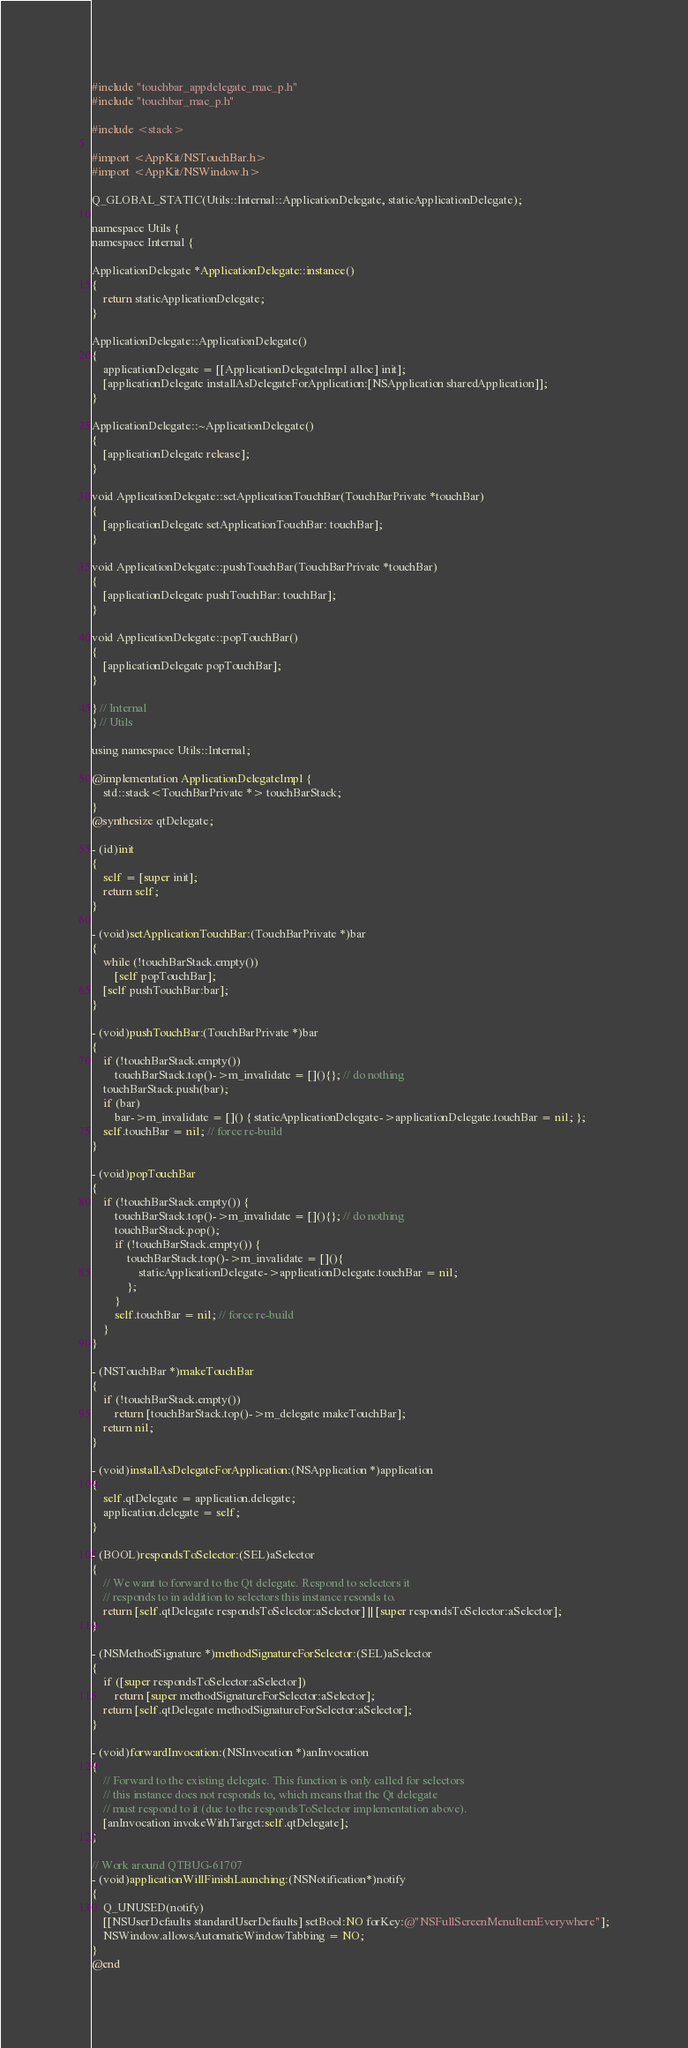<code> <loc_0><loc_0><loc_500><loc_500><_ObjectiveC_>#include "touchbar_appdelegate_mac_p.h"
#include "touchbar_mac_p.h"

#include <stack>

#import <AppKit/NSTouchBar.h>
#import <AppKit/NSWindow.h>

Q_GLOBAL_STATIC(Utils::Internal::ApplicationDelegate, staticApplicationDelegate);

namespace Utils {
namespace Internal {

ApplicationDelegate *ApplicationDelegate::instance()
{
    return staticApplicationDelegate;
}

ApplicationDelegate::ApplicationDelegate()
{
    applicationDelegate = [[ApplicationDelegateImpl alloc] init];
    [applicationDelegate installAsDelegateForApplication:[NSApplication sharedApplication]];
}

ApplicationDelegate::~ApplicationDelegate()
{
    [applicationDelegate release];
}

void ApplicationDelegate::setApplicationTouchBar(TouchBarPrivate *touchBar)
{
    [applicationDelegate setApplicationTouchBar: touchBar];
}

void ApplicationDelegate::pushTouchBar(TouchBarPrivate *touchBar)
{
    [applicationDelegate pushTouchBar: touchBar];
}

void ApplicationDelegate::popTouchBar()
{
    [applicationDelegate popTouchBar];
}

} // Internal
} // Utils

using namespace Utils::Internal;

@implementation ApplicationDelegateImpl {
    std::stack<TouchBarPrivate *> touchBarStack;
}
@synthesize qtDelegate;

- (id)init
{
    self = [super init];
    return self;
}

- (void)setApplicationTouchBar:(TouchBarPrivate *)bar
{
    while (!touchBarStack.empty())
        [self popTouchBar];
    [self pushTouchBar:bar];
}

- (void)pushTouchBar:(TouchBarPrivate *)bar
{
    if (!touchBarStack.empty())
        touchBarStack.top()->m_invalidate = [](){}; // do nothing
    touchBarStack.push(bar);
    if (bar)
        bar->m_invalidate = []() { staticApplicationDelegate->applicationDelegate.touchBar = nil; };
    self.touchBar = nil; // force re-build
}

- (void)popTouchBar
{
    if (!touchBarStack.empty()) {
        touchBarStack.top()->m_invalidate = [](){}; // do nothing
        touchBarStack.pop();
        if (!touchBarStack.empty()) {
            touchBarStack.top()->m_invalidate = [](){
                staticApplicationDelegate->applicationDelegate.touchBar = nil;
            };
        }
        self.touchBar = nil; // force re-build
    }
}

- (NSTouchBar *)makeTouchBar
{
    if (!touchBarStack.empty())
        return [touchBarStack.top()->m_delegate makeTouchBar];
    return nil;
}

- (void)installAsDelegateForApplication:(NSApplication *)application
{
    self.qtDelegate = application.delegate;
    application.delegate = self;
}

- (BOOL)respondsToSelector:(SEL)aSelector
{
    // We want to forward to the Qt delegate. Respond to selectors it
    // responds to in addition to selectors this instance resonds to.
    return [self.qtDelegate respondsToSelector:aSelector] || [super respondsToSelector:aSelector];
}

- (NSMethodSignature *)methodSignatureForSelector:(SEL)aSelector
{
    if ([super respondsToSelector:aSelector])
        return [super methodSignatureForSelector:aSelector];
    return [self.qtDelegate methodSignatureForSelector:aSelector];
}

- (void)forwardInvocation:(NSInvocation *)anInvocation
{
    // Forward to the existing delegate. This function is only called for selectors
    // this instance does not responds to, which means that the Qt delegate
    // must respond to it (due to the respondsToSelector implementation above).
    [anInvocation invokeWithTarget:self.qtDelegate];
}

// Work around QTBUG-61707
- (void)applicationWillFinishLaunching:(NSNotification*)notify
{
    Q_UNUSED(notify)
    [[NSUserDefaults standardUserDefaults] setBool:NO forKey:@"NSFullScreenMenuItemEverywhere"];
    NSWindow.allowsAutomaticWindowTabbing = NO;
}
@end
</code> 